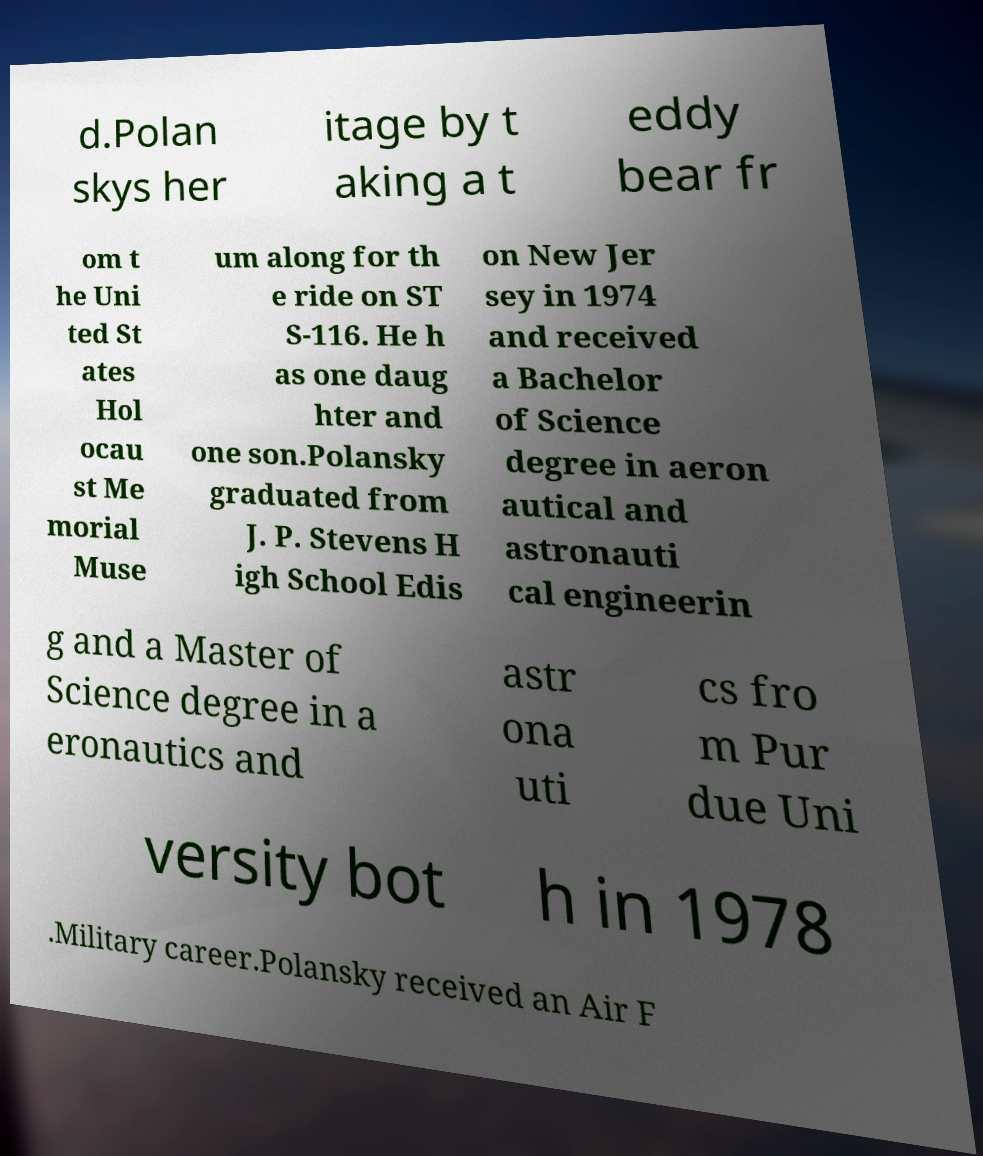Could you extract and type out the text from this image? d.Polan skys her itage by t aking a t eddy bear fr om t he Uni ted St ates Hol ocau st Me morial Muse um along for th e ride on ST S-116. He h as one daug hter and one son.Polansky graduated from J. P. Stevens H igh School Edis on New Jer sey in 1974 and received a Bachelor of Science degree in aeron autical and astronauti cal engineerin g and a Master of Science degree in a eronautics and astr ona uti cs fro m Pur due Uni versity bot h in 1978 .Military career.Polansky received an Air F 